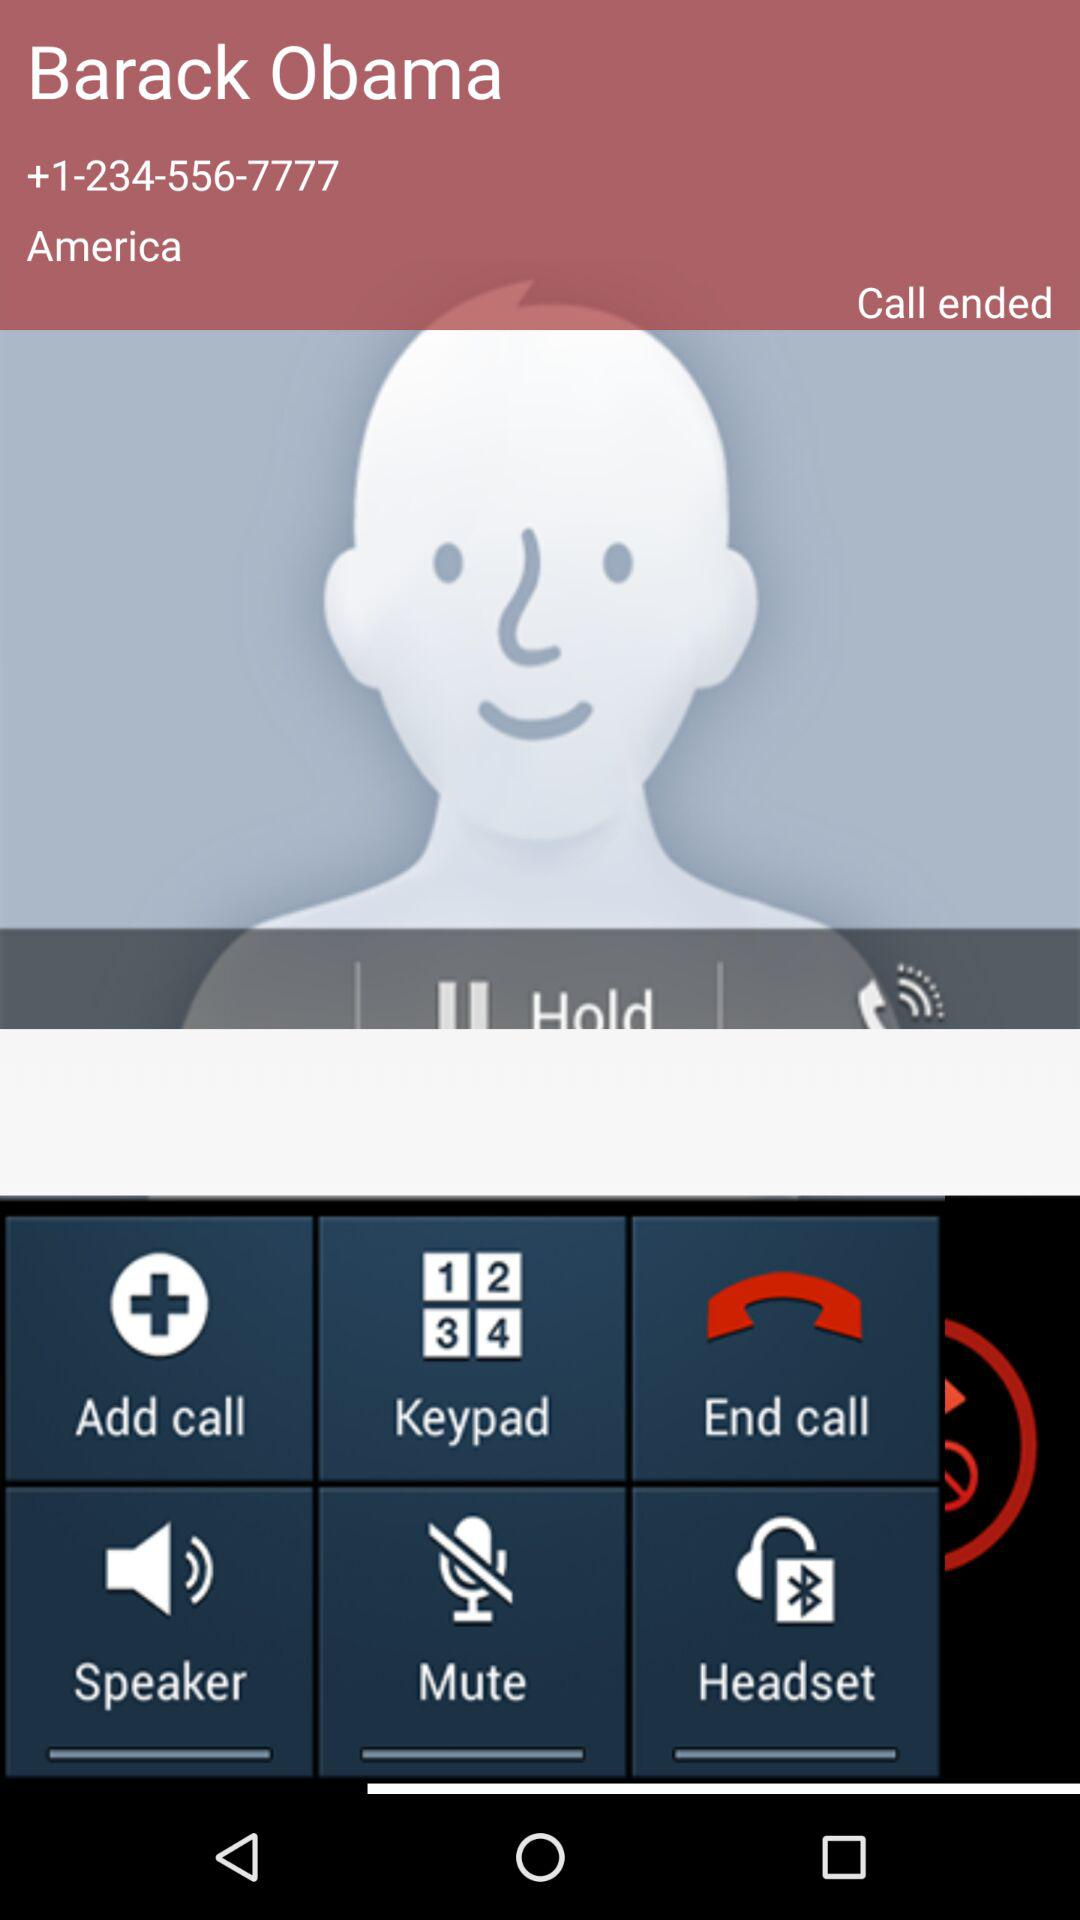What is the name shown on the screen? The name shown on the screen is Barack Obama. 